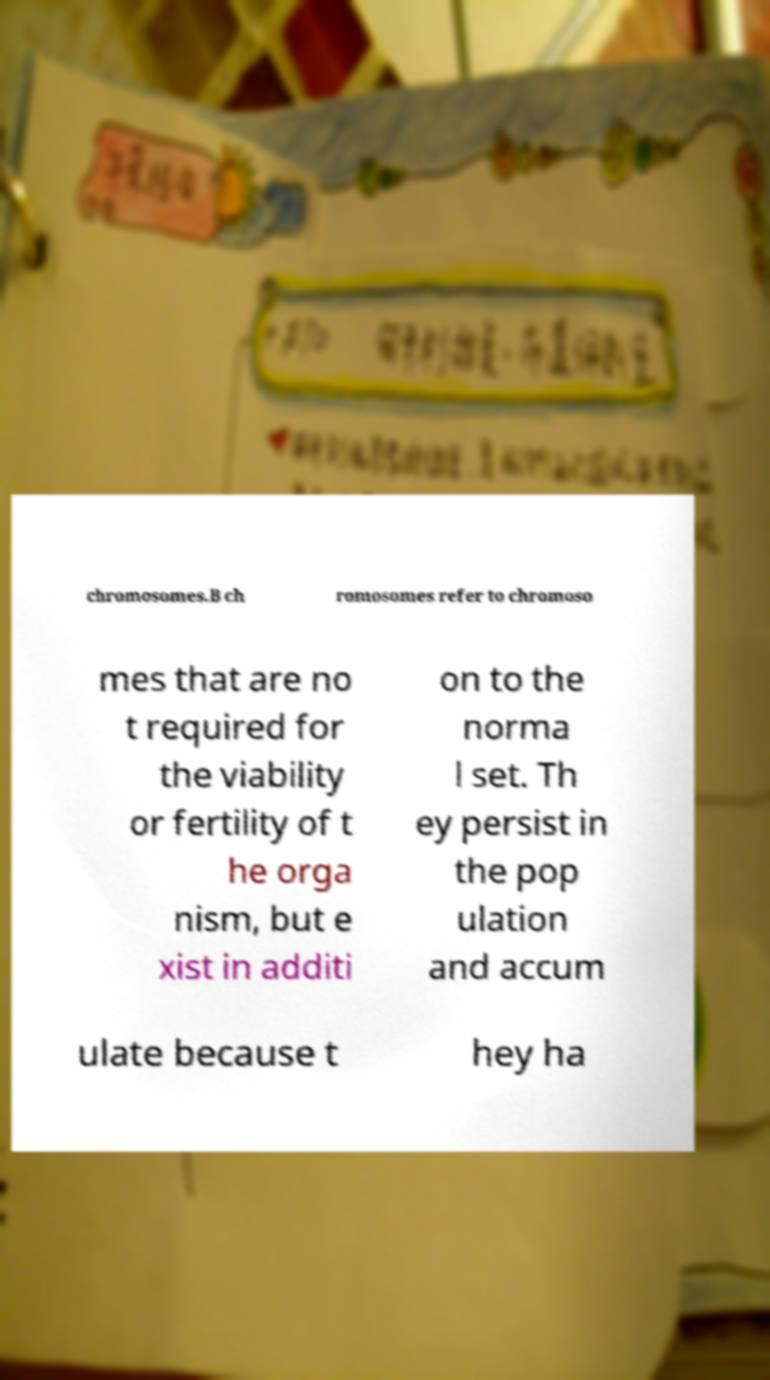Please read and relay the text visible in this image. What does it say? chromosomes.B ch romosomes refer to chromoso mes that are no t required for the viability or fertility of t he orga nism, but e xist in additi on to the norma l set. Th ey persist in the pop ulation and accum ulate because t hey ha 